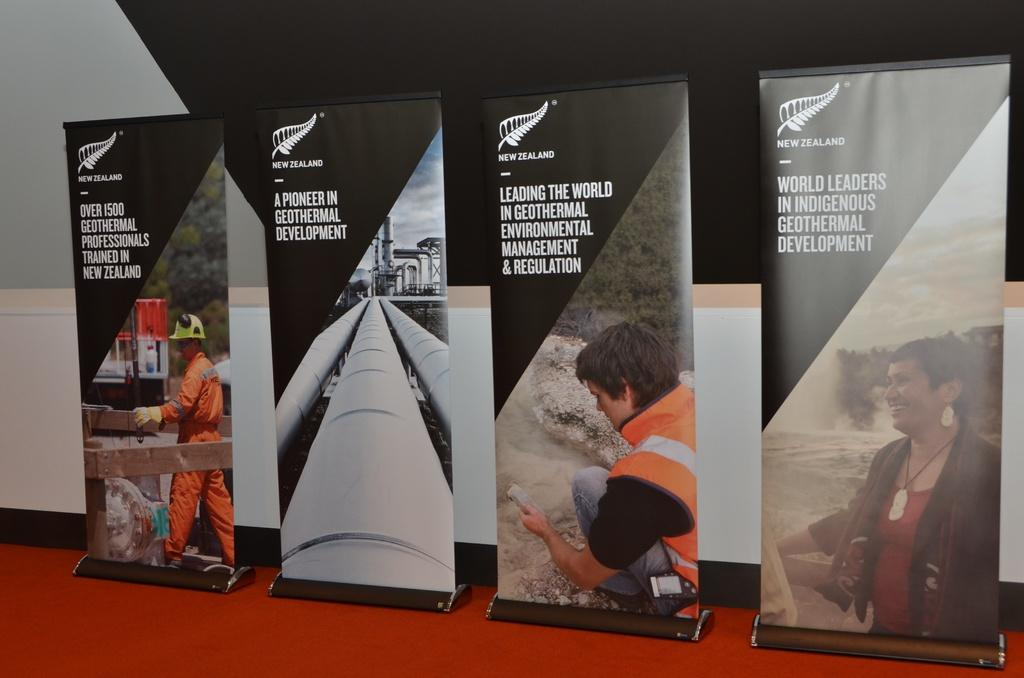<image>
Write a terse but informative summary of the picture. four different large standing banners for New Zealand. 